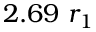<formula> <loc_0><loc_0><loc_500><loc_500>2 . 6 9 r _ { 1 }</formula> 